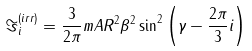Convert formula to latex. <formula><loc_0><loc_0><loc_500><loc_500>\Im ^ { ( i r r ) } _ { i } = \frac { 3 } { 2 \pi } m A R ^ { 2 } \beta ^ { 2 } \sin ^ { 2 } \left ( \gamma - \frac { 2 \pi } { 3 } i \right )</formula> 